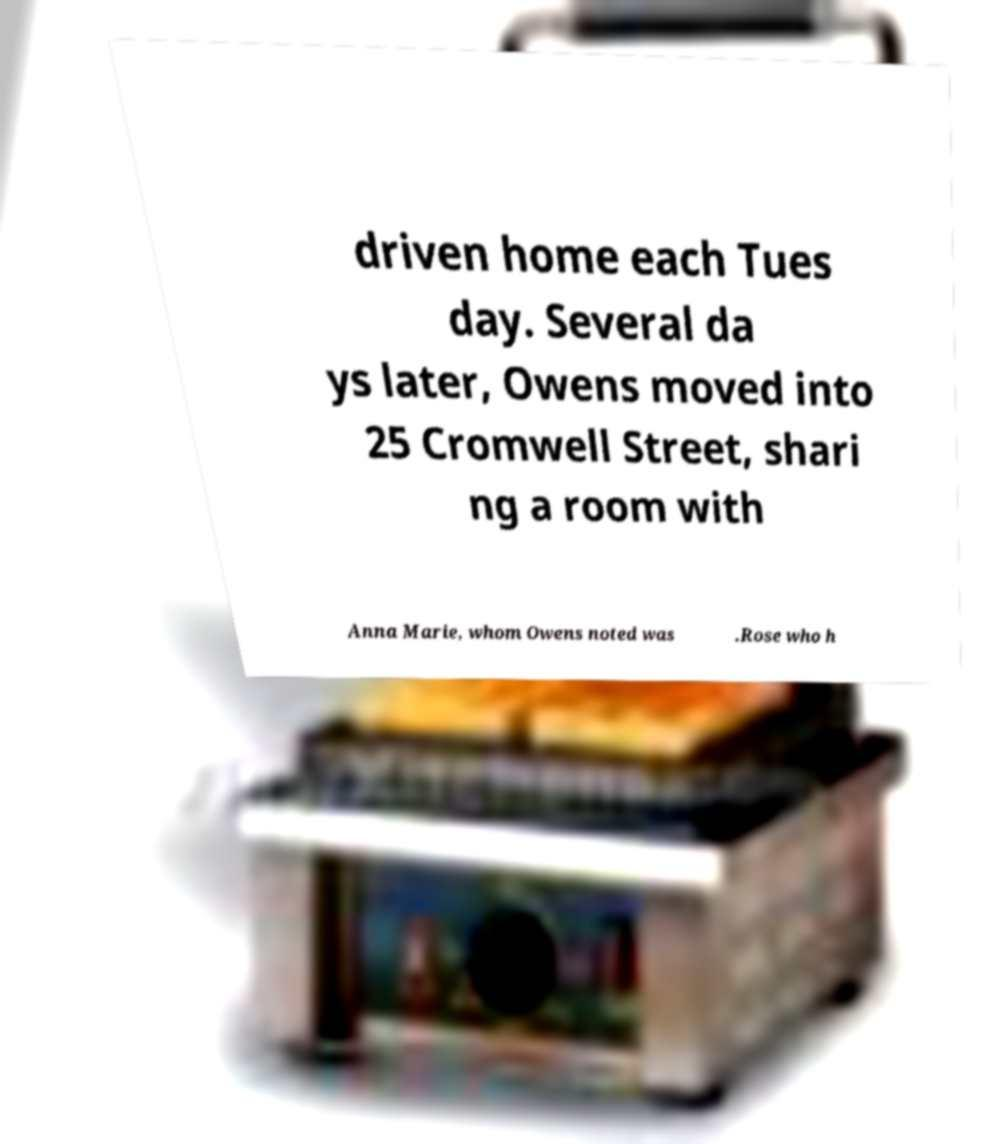For documentation purposes, I need the text within this image transcribed. Could you provide that? driven home each Tues day. Several da ys later, Owens moved into 25 Cromwell Street, shari ng a room with Anna Marie, whom Owens noted was .Rose who h 